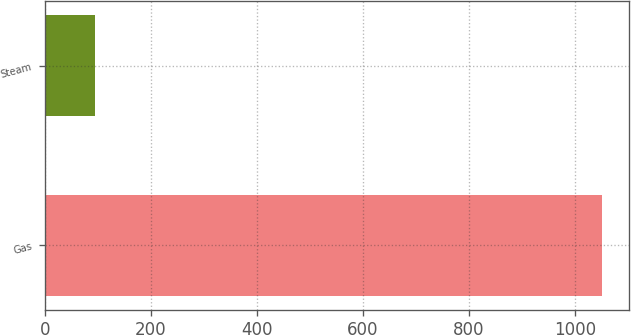<chart> <loc_0><loc_0><loc_500><loc_500><bar_chart><fcel>Gas<fcel>Steam<nl><fcel>1050<fcel>94<nl></chart> 